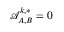Convert formula to latex. <formula><loc_0><loc_0><loc_500><loc_500>\mathcal { A } _ { A , B } ^ { k , * } = 0</formula> 